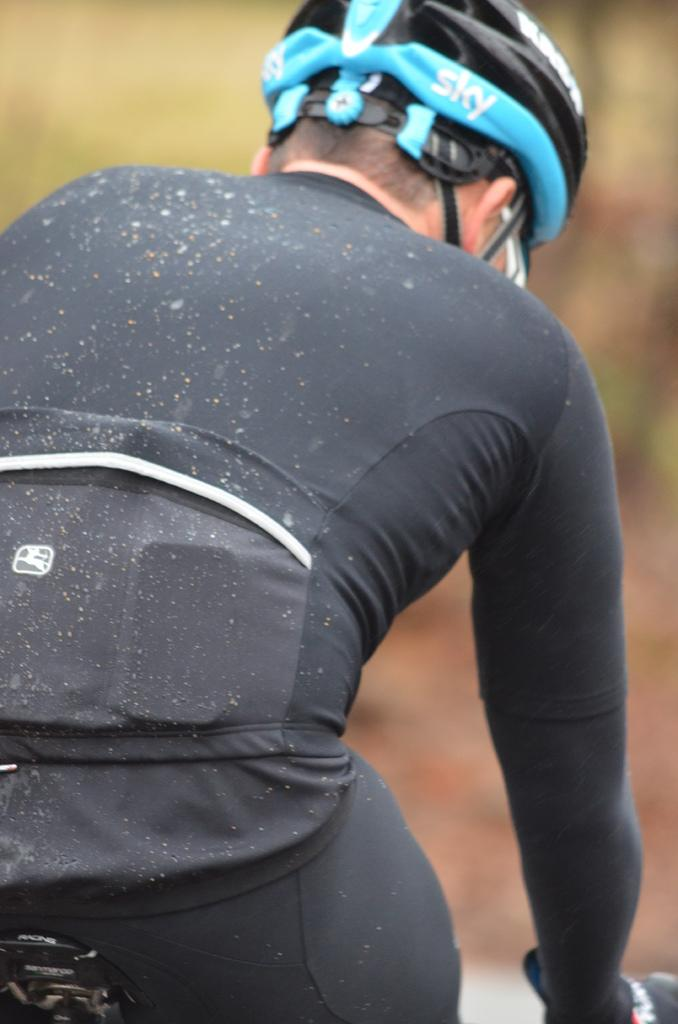What is the main subject of the image? There is a person in the image. What is the person wearing on their head? The person is wearing a helmet. Can you describe the background of the image? The background of the image is blurry. What type of deer can be seen in the background of the image? There is no deer present in the image; the background is blurry. What tool is the laborer using in the image? There is no laborer or tool present in the image; it features a person wearing a helmet. 